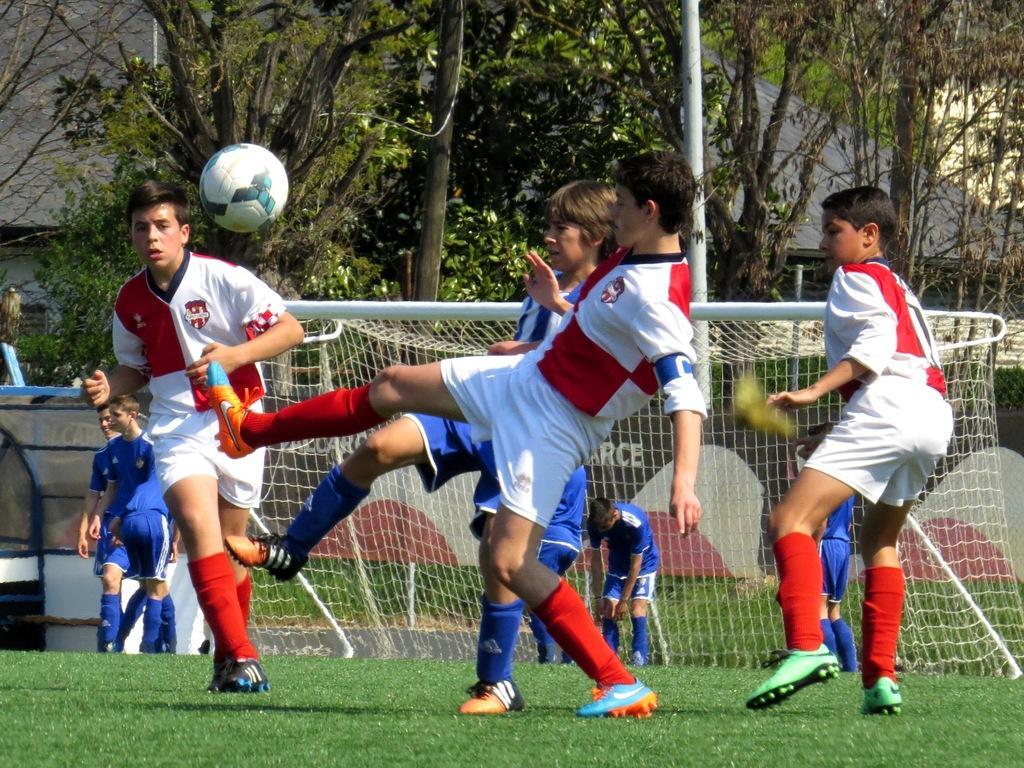Describe this image in one or two sentences. This image is taken outdoors. At the bottom of the image there is a ground with grass on it. In the background there are a few trees and a board with text on it and there is a building. In the middle of the image a few boys are playing football with a ball and there is a goal court. 